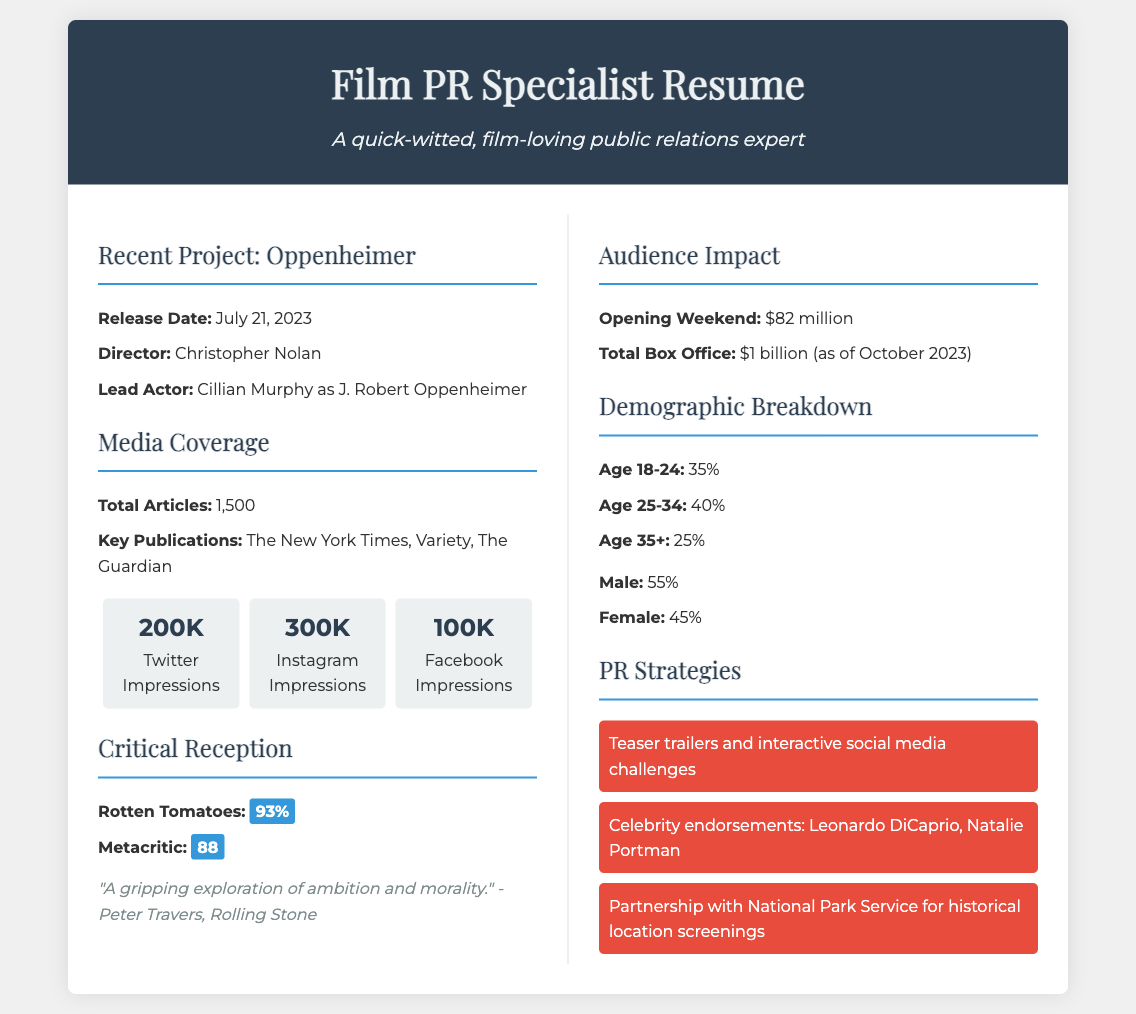What is the release date of Oppenheimer? The release date of Oppenheimer is specifically mentioned in the document.
Answer: July 21, 2023 Who directed Oppenheimer? The document explicitly states the director associated with the film.
Answer: Christopher Nolan How many total articles covered Oppenheimer? The number of total articles is listed under the media coverage section.
Answer: 1,500 What was the opening weekend revenue for Oppenheimer? The opening weekend revenue is provided in the audience impact section of the document.
Answer: $82 million What percentage did Rotten Tomatoes give Oppenheimer? The percentage given by Rotten Tomatoes is highlighted in the critical reception section.
Answer: 93% What is the demographic percentage for ages 25-34? The specific demographic percentage is detailed in the demographic breakdown section.
Answer: 40% Which celebrity endorsed Oppenheimer in the PR strategies? The PR strategies section lists specific celebrities who endorsed the film.
Answer: Leonardo DiCaprio What was the total box office revenue as of October 2023? The total box office revenue is stated in the audience impact section and represents accumulated earnings.
Answer: $1 billion What is the male demographic percentage for Oppenheimer? The male demographic percentage is clearly noted in the document.
Answer: 55% 